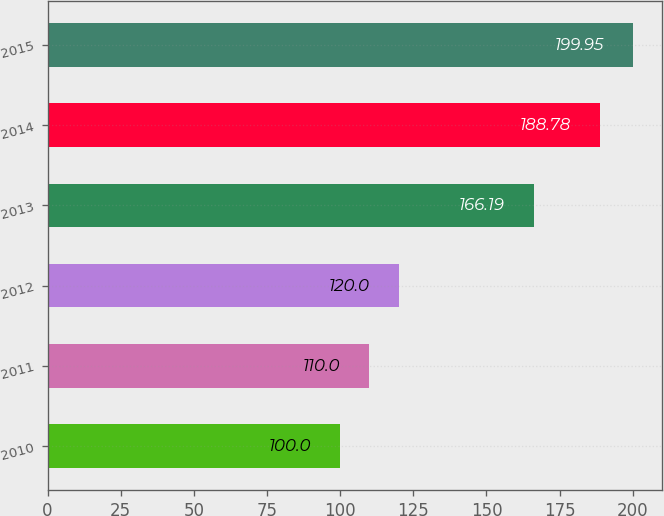Convert chart to OTSL. <chart><loc_0><loc_0><loc_500><loc_500><bar_chart><fcel>2010<fcel>2011<fcel>2012<fcel>2013<fcel>2014<fcel>2015<nl><fcel>100<fcel>110<fcel>120<fcel>166.19<fcel>188.78<fcel>199.95<nl></chart> 